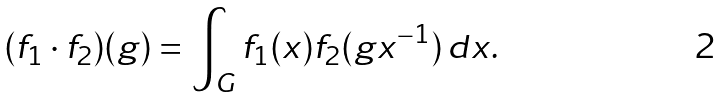Convert formula to latex. <formula><loc_0><loc_0><loc_500><loc_500>( f _ { 1 } \cdot f _ { 2 } ) ( g ) = \int _ { G } f _ { 1 } ( x ) f _ { 2 } ( g x ^ { - 1 } ) \, d x .</formula> 